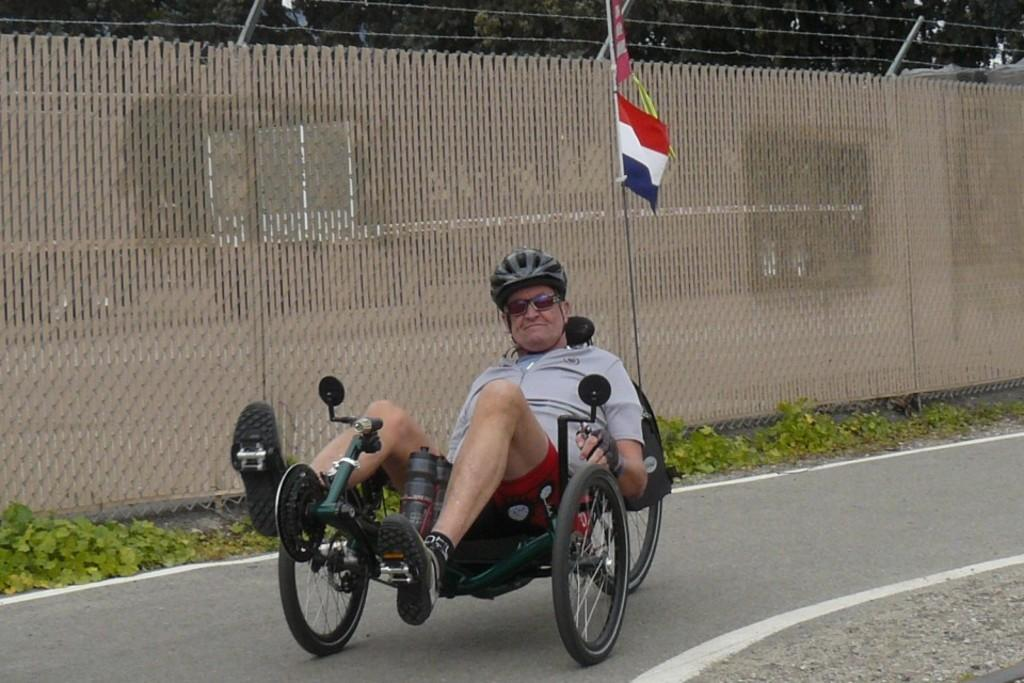What is the man in the image using to move around? The man in the image is sitting on a wheelchair. What type of natural environment is visible in the image? There are many trees and plants in the image. What type of pathway is present in the image? There is a road in the image. What is the symbolic object visible in the image? There is a flag in the image. What type of barrier is present in the image? There is a fencing in the image. What type of club is the man holding in the image? There is no club present in the image; the man is sitting on a wheelchair. What is the topic of the discussion taking place in the image? There is no discussion taking place in the image, as it is a still image. 